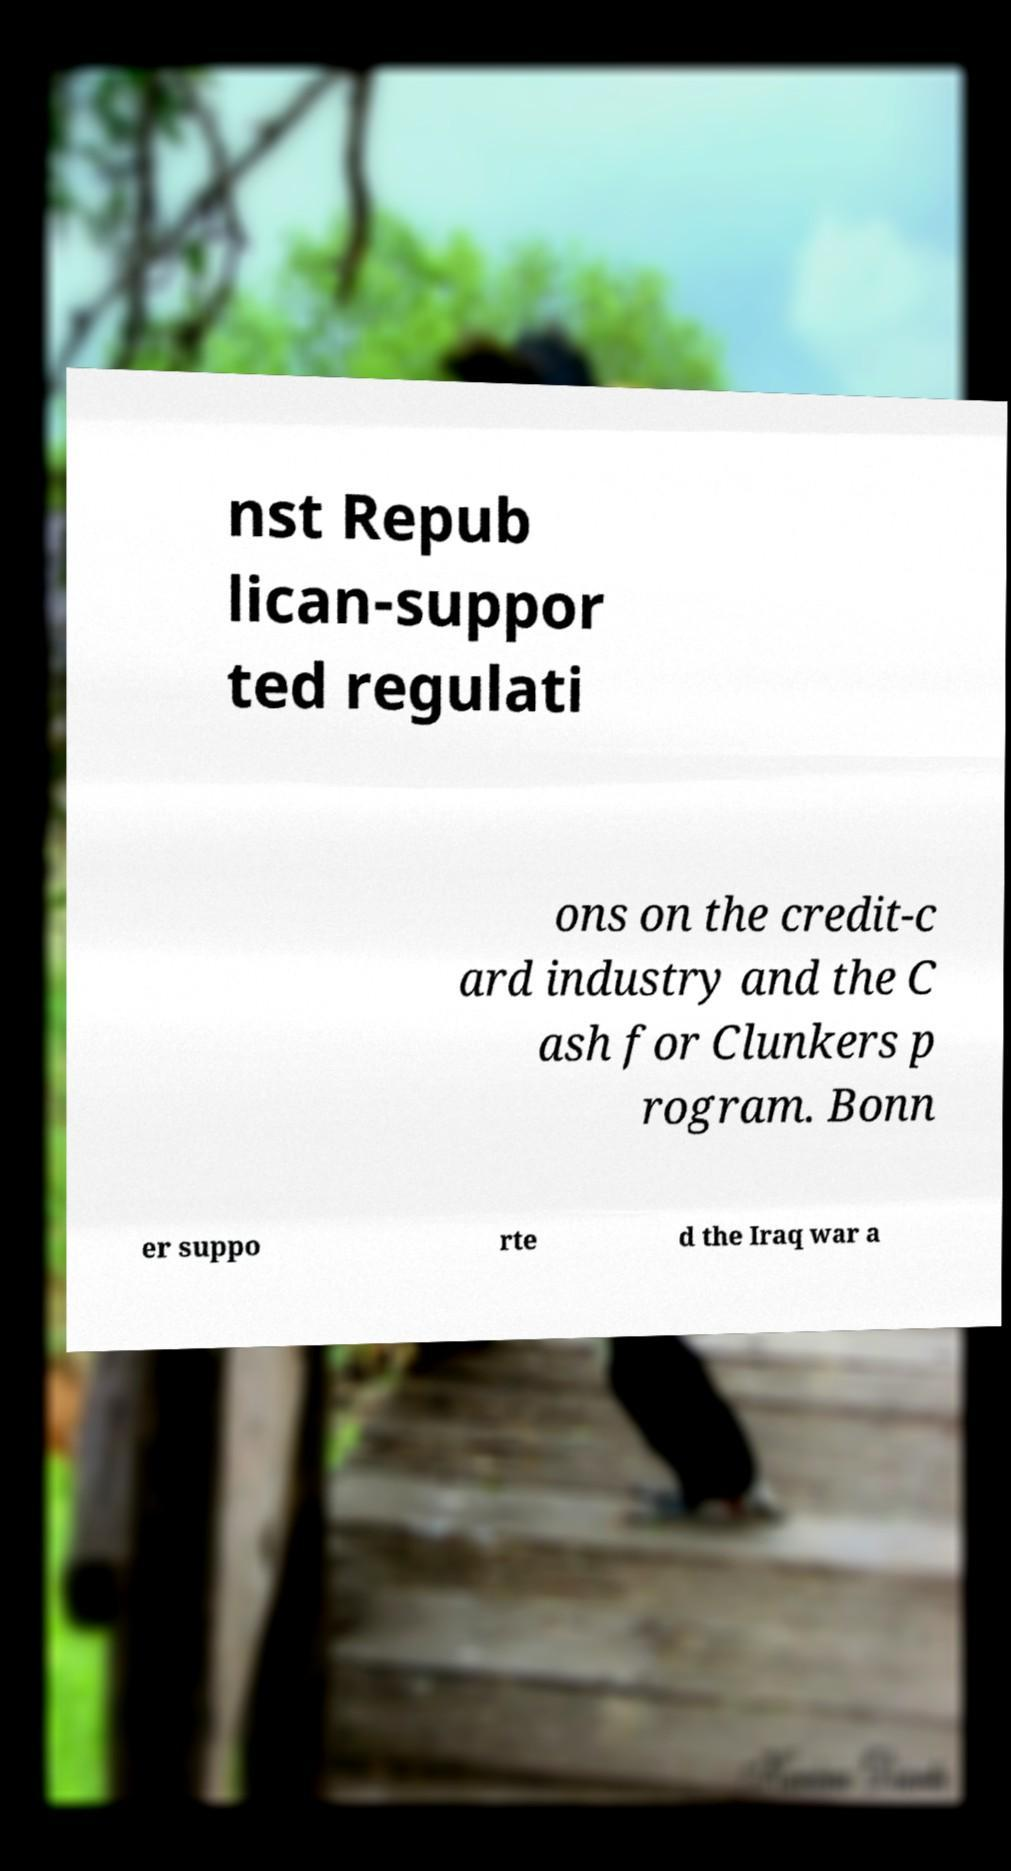I need the written content from this picture converted into text. Can you do that? nst Repub lican-suppor ted regulati ons on the credit-c ard industry and the C ash for Clunkers p rogram. Bonn er suppo rte d the Iraq war a 